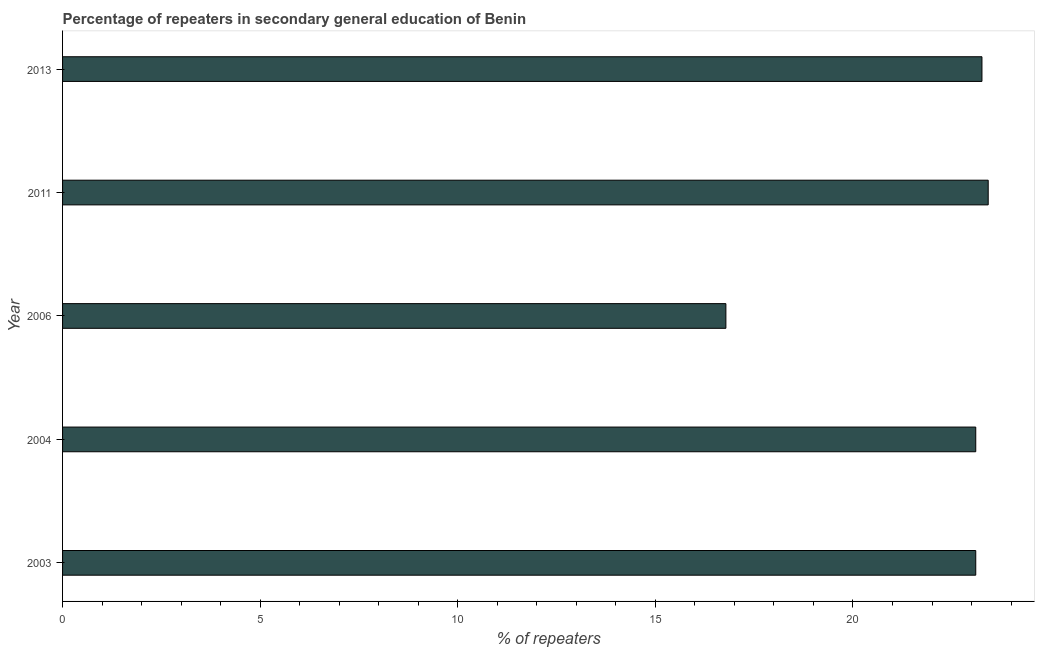What is the title of the graph?
Provide a succinct answer. Percentage of repeaters in secondary general education of Benin. What is the label or title of the X-axis?
Offer a terse response. % of repeaters. What is the percentage of repeaters in 2003?
Provide a succinct answer. 23.11. Across all years, what is the maximum percentage of repeaters?
Ensure brevity in your answer.  23.42. Across all years, what is the minimum percentage of repeaters?
Offer a very short reply. 16.78. In which year was the percentage of repeaters minimum?
Ensure brevity in your answer.  2006. What is the sum of the percentage of repeaters?
Your response must be concise. 109.69. What is the difference between the percentage of repeaters in 2006 and 2013?
Ensure brevity in your answer.  -6.48. What is the average percentage of repeaters per year?
Your answer should be very brief. 21.94. What is the median percentage of repeaters?
Ensure brevity in your answer.  23.11. Do a majority of the years between 2006 and 2013 (inclusive) have percentage of repeaters greater than 18 %?
Your response must be concise. Yes. What is the ratio of the percentage of repeaters in 2006 to that in 2011?
Your answer should be very brief. 0.72. What is the difference between the highest and the second highest percentage of repeaters?
Your response must be concise. 0.16. Is the sum of the percentage of repeaters in 2003 and 2013 greater than the maximum percentage of repeaters across all years?
Offer a terse response. Yes. What is the difference between the highest and the lowest percentage of repeaters?
Ensure brevity in your answer.  6.64. How many bars are there?
Provide a succinct answer. 5. Are all the bars in the graph horizontal?
Ensure brevity in your answer.  Yes. How many years are there in the graph?
Your response must be concise. 5. What is the % of repeaters in 2003?
Offer a very short reply. 23.11. What is the % of repeaters of 2004?
Your response must be concise. 23.11. What is the % of repeaters of 2006?
Offer a terse response. 16.78. What is the % of repeaters in 2011?
Your answer should be compact. 23.42. What is the % of repeaters of 2013?
Make the answer very short. 23.26. What is the difference between the % of repeaters in 2003 and 2004?
Give a very brief answer. -0. What is the difference between the % of repeaters in 2003 and 2006?
Give a very brief answer. 6.32. What is the difference between the % of repeaters in 2003 and 2011?
Your answer should be compact. -0.32. What is the difference between the % of repeaters in 2003 and 2013?
Your answer should be very brief. -0.16. What is the difference between the % of repeaters in 2004 and 2006?
Your response must be concise. 6.32. What is the difference between the % of repeaters in 2004 and 2011?
Give a very brief answer. -0.32. What is the difference between the % of repeaters in 2004 and 2013?
Your answer should be very brief. -0.16. What is the difference between the % of repeaters in 2006 and 2011?
Ensure brevity in your answer.  -6.64. What is the difference between the % of repeaters in 2006 and 2013?
Your answer should be very brief. -6.48. What is the difference between the % of repeaters in 2011 and 2013?
Your answer should be compact. 0.16. What is the ratio of the % of repeaters in 2003 to that in 2004?
Your response must be concise. 1. What is the ratio of the % of repeaters in 2003 to that in 2006?
Make the answer very short. 1.38. What is the ratio of the % of repeaters in 2003 to that in 2013?
Your answer should be compact. 0.99. What is the ratio of the % of repeaters in 2004 to that in 2006?
Offer a very short reply. 1.38. What is the ratio of the % of repeaters in 2004 to that in 2011?
Provide a succinct answer. 0.99. What is the ratio of the % of repeaters in 2006 to that in 2011?
Offer a terse response. 0.72. What is the ratio of the % of repeaters in 2006 to that in 2013?
Make the answer very short. 0.72. What is the ratio of the % of repeaters in 2011 to that in 2013?
Provide a short and direct response. 1.01. 